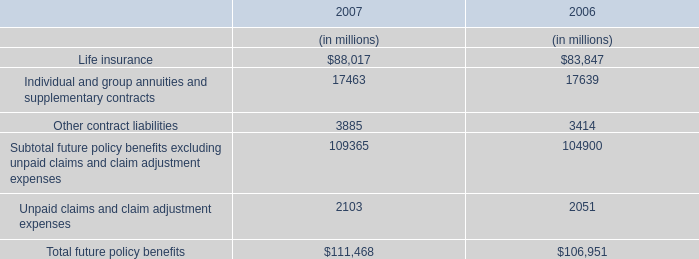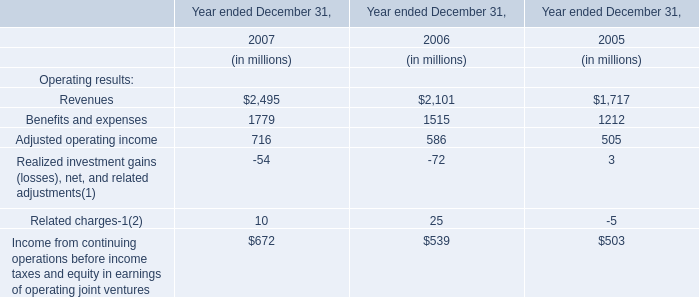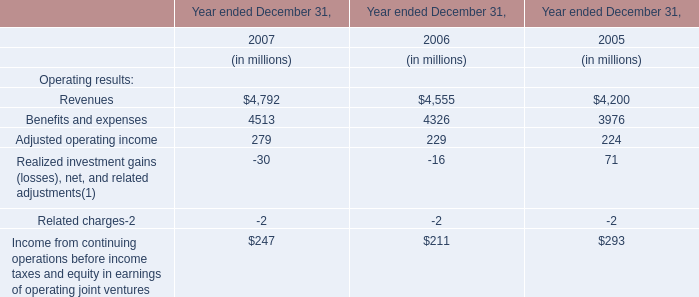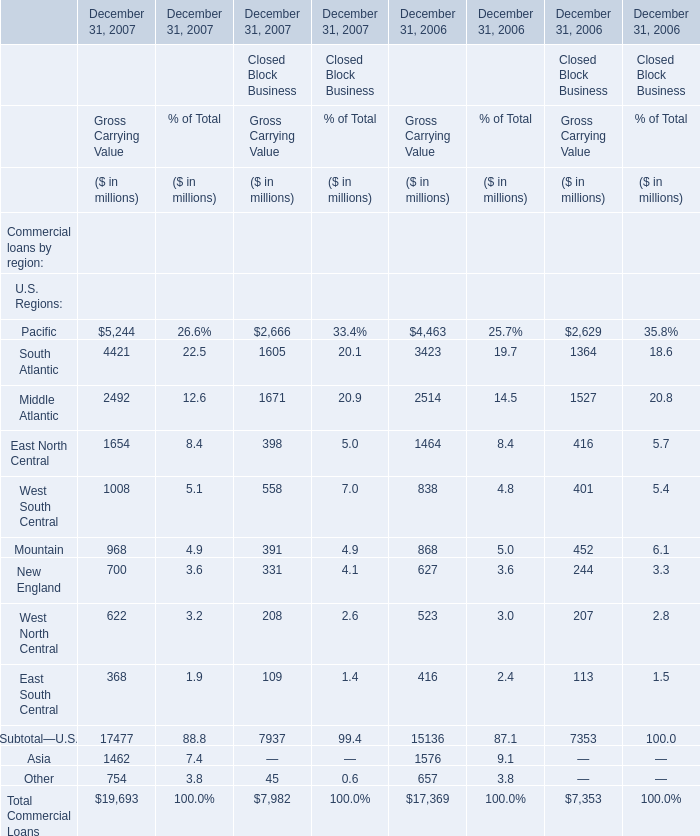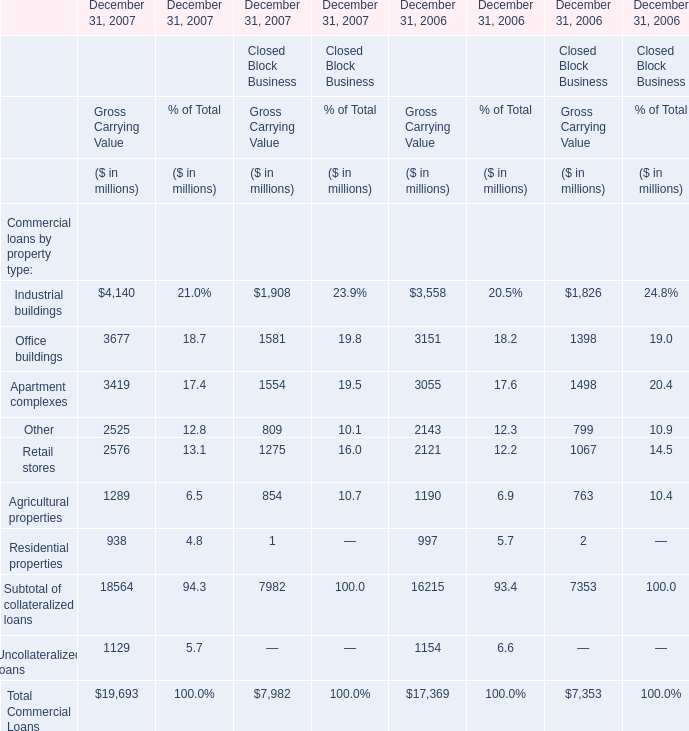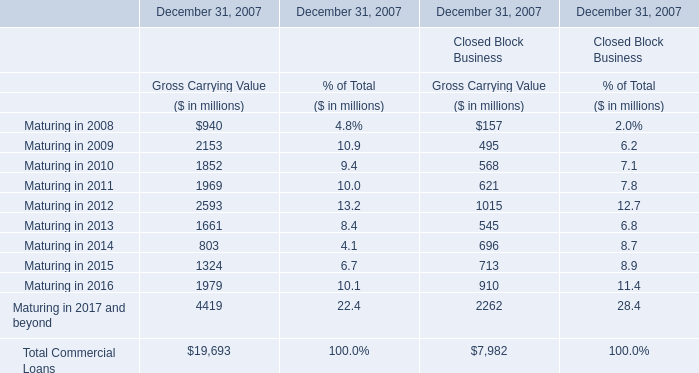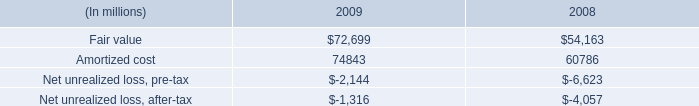Which section is Industrial buildings the highest for Financial Services Businesses? 
Answer: Gross Carrying Value. 